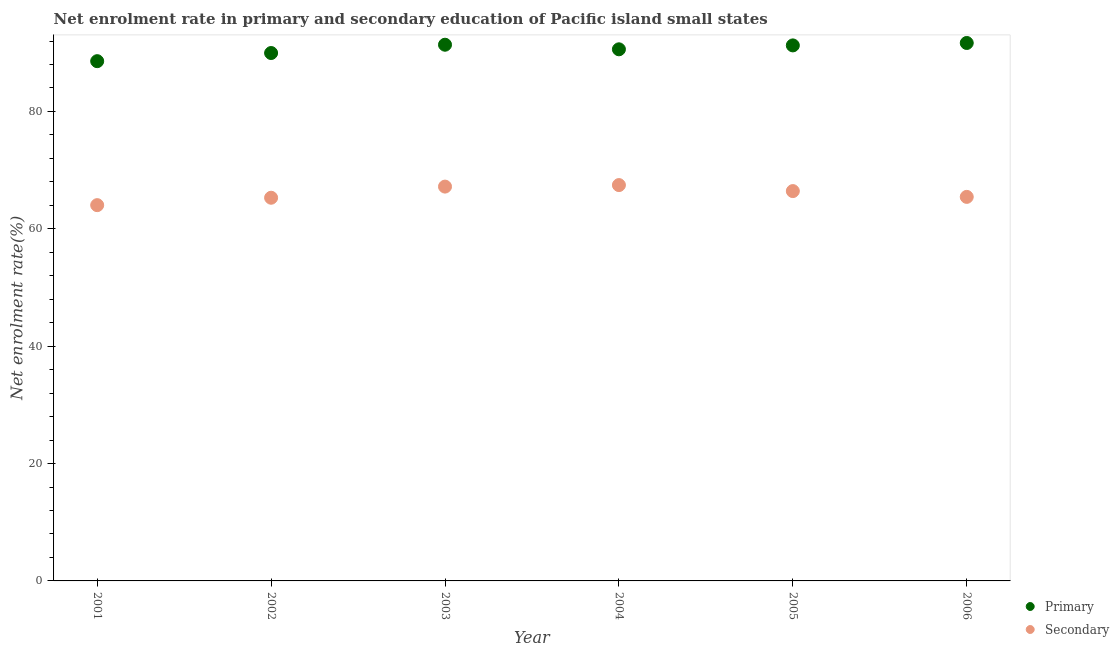What is the enrollment rate in secondary education in 2001?
Offer a very short reply. 64.03. Across all years, what is the maximum enrollment rate in primary education?
Make the answer very short. 91.66. Across all years, what is the minimum enrollment rate in primary education?
Your answer should be compact. 88.56. In which year was the enrollment rate in secondary education maximum?
Your answer should be very brief. 2004. In which year was the enrollment rate in secondary education minimum?
Your answer should be compact. 2001. What is the total enrollment rate in primary education in the graph?
Give a very brief answer. 543.38. What is the difference between the enrollment rate in secondary education in 2004 and that in 2006?
Your answer should be compact. 2.01. What is the difference between the enrollment rate in primary education in 2003 and the enrollment rate in secondary education in 2002?
Your answer should be compact. 26.07. What is the average enrollment rate in primary education per year?
Your response must be concise. 90.56. In the year 2003, what is the difference between the enrollment rate in primary education and enrollment rate in secondary education?
Give a very brief answer. 24.18. In how many years, is the enrollment rate in primary education greater than 68 %?
Give a very brief answer. 6. What is the ratio of the enrollment rate in secondary education in 2004 to that in 2005?
Offer a very short reply. 1.02. Is the enrollment rate in primary education in 2002 less than that in 2004?
Ensure brevity in your answer.  Yes. What is the difference between the highest and the second highest enrollment rate in secondary education?
Your answer should be very brief. 0.26. What is the difference between the highest and the lowest enrollment rate in primary education?
Ensure brevity in your answer.  3.1. In how many years, is the enrollment rate in primary education greater than the average enrollment rate in primary education taken over all years?
Your answer should be compact. 4. Is the sum of the enrollment rate in secondary education in 2005 and 2006 greater than the maximum enrollment rate in primary education across all years?
Ensure brevity in your answer.  Yes. Is the enrollment rate in secondary education strictly less than the enrollment rate in primary education over the years?
Offer a terse response. Yes. How many dotlines are there?
Give a very brief answer. 2. How many years are there in the graph?
Your answer should be compact. 6. Does the graph contain any zero values?
Ensure brevity in your answer.  No. How many legend labels are there?
Your answer should be very brief. 2. How are the legend labels stacked?
Offer a very short reply. Vertical. What is the title of the graph?
Make the answer very short. Net enrolment rate in primary and secondary education of Pacific island small states. Does "Education" appear as one of the legend labels in the graph?
Make the answer very short. No. What is the label or title of the Y-axis?
Offer a very short reply. Net enrolment rate(%). What is the Net enrolment rate(%) of Primary in 2001?
Give a very brief answer. 88.56. What is the Net enrolment rate(%) in Secondary in 2001?
Offer a very short reply. 64.03. What is the Net enrolment rate(%) of Primary in 2002?
Provide a succinct answer. 89.95. What is the Net enrolment rate(%) in Secondary in 2002?
Your response must be concise. 65.29. What is the Net enrolment rate(%) in Primary in 2003?
Offer a very short reply. 91.37. What is the Net enrolment rate(%) in Secondary in 2003?
Your answer should be compact. 67.19. What is the Net enrolment rate(%) in Primary in 2004?
Your response must be concise. 90.58. What is the Net enrolment rate(%) in Secondary in 2004?
Ensure brevity in your answer.  67.45. What is the Net enrolment rate(%) of Primary in 2005?
Provide a succinct answer. 91.25. What is the Net enrolment rate(%) in Secondary in 2005?
Give a very brief answer. 66.43. What is the Net enrolment rate(%) of Primary in 2006?
Your answer should be compact. 91.66. What is the Net enrolment rate(%) in Secondary in 2006?
Ensure brevity in your answer.  65.44. Across all years, what is the maximum Net enrolment rate(%) in Primary?
Keep it short and to the point. 91.66. Across all years, what is the maximum Net enrolment rate(%) of Secondary?
Give a very brief answer. 67.45. Across all years, what is the minimum Net enrolment rate(%) of Primary?
Offer a terse response. 88.56. Across all years, what is the minimum Net enrolment rate(%) in Secondary?
Provide a short and direct response. 64.03. What is the total Net enrolment rate(%) in Primary in the graph?
Provide a succinct answer. 543.38. What is the total Net enrolment rate(%) in Secondary in the graph?
Provide a succinct answer. 395.83. What is the difference between the Net enrolment rate(%) in Primary in 2001 and that in 2002?
Your response must be concise. -1.39. What is the difference between the Net enrolment rate(%) in Secondary in 2001 and that in 2002?
Offer a very short reply. -1.26. What is the difference between the Net enrolment rate(%) in Primary in 2001 and that in 2003?
Offer a terse response. -2.8. What is the difference between the Net enrolment rate(%) in Secondary in 2001 and that in 2003?
Offer a very short reply. -3.16. What is the difference between the Net enrolment rate(%) of Primary in 2001 and that in 2004?
Provide a short and direct response. -2.02. What is the difference between the Net enrolment rate(%) of Secondary in 2001 and that in 2004?
Make the answer very short. -3.42. What is the difference between the Net enrolment rate(%) of Primary in 2001 and that in 2005?
Your answer should be compact. -2.69. What is the difference between the Net enrolment rate(%) in Secondary in 2001 and that in 2005?
Offer a terse response. -2.39. What is the difference between the Net enrolment rate(%) in Primary in 2001 and that in 2006?
Make the answer very short. -3.1. What is the difference between the Net enrolment rate(%) of Secondary in 2001 and that in 2006?
Make the answer very short. -1.41. What is the difference between the Net enrolment rate(%) of Primary in 2002 and that in 2003?
Your answer should be compact. -1.41. What is the difference between the Net enrolment rate(%) of Secondary in 2002 and that in 2003?
Ensure brevity in your answer.  -1.9. What is the difference between the Net enrolment rate(%) of Primary in 2002 and that in 2004?
Your response must be concise. -0.63. What is the difference between the Net enrolment rate(%) in Secondary in 2002 and that in 2004?
Provide a succinct answer. -2.16. What is the difference between the Net enrolment rate(%) in Primary in 2002 and that in 2005?
Offer a terse response. -1.3. What is the difference between the Net enrolment rate(%) of Secondary in 2002 and that in 2005?
Give a very brief answer. -1.13. What is the difference between the Net enrolment rate(%) of Primary in 2002 and that in 2006?
Ensure brevity in your answer.  -1.71. What is the difference between the Net enrolment rate(%) in Secondary in 2002 and that in 2006?
Offer a very short reply. -0.15. What is the difference between the Net enrolment rate(%) in Primary in 2003 and that in 2004?
Give a very brief answer. 0.78. What is the difference between the Net enrolment rate(%) in Secondary in 2003 and that in 2004?
Ensure brevity in your answer.  -0.26. What is the difference between the Net enrolment rate(%) in Primary in 2003 and that in 2005?
Offer a terse response. 0.12. What is the difference between the Net enrolment rate(%) of Secondary in 2003 and that in 2005?
Offer a terse response. 0.77. What is the difference between the Net enrolment rate(%) in Primary in 2003 and that in 2006?
Provide a short and direct response. -0.3. What is the difference between the Net enrolment rate(%) of Secondary in 2003 and that in 2006?
Your answer should be compact. 1.75. What is the difference between the Net enrolment rate(%) in Primary in 2004 and that in 2005?
Ensure brevity in your answer.  -0.67. What is the difference between the Net enrolment rate(%) in Secondary in 2004 and that in 2005?
Your answer should be very brief. 1.02. What is the difference between the Net enrolment rate(%) in Primary in 2004 and that in 2006?
Make the answer very short. -1.08. What is the difference between the Net enrolment rate(%) in Secondary in 2004 and that in 2006?
Your answer should be very brief. 2.01. What is the difference between the Net enrolment rate(%) in Primary in 2005 and that in 2006?
Ensure brevity in your answer.  -0.41. What is the difference between the Net enrolment rate(%) in Secondary in 2005 and that in 2006?
Your answer should be compact. 0.99. What is the difference between the Net enrolment rate(%) of Primary in 2001 and the Net enrolment rate(%) of Secondary in 2002?
Provide a short and direct response. 23.27. What is the difference between the Net enrolment rate(%) in Primary in 2001 and the Net enrolment rate(%) in Secondary in 2003?
Your answer should be compact. 21.37. What is the difference between the Net enrolment rate(%) of Primary in 2001 and the Net enrolment rate(%) of Secondary in 2004?
Offer a terse response. 21.11. What is the difference between the Net enrolment rate(%) in Primary in 2001 and the Net enrolment rate(%) in Secondary in 2005?
Keep it short and to the point. 22.14. What is the difference between the Net enrolment rate(%) of Primary in 2001 and the Net enrolment rate(%) of Secondary in 2006?
Provide a short and direct response. 23.12. What is the difference between the Net enrolment rate(%) of Primary in 2002 and the Net enrolment rate(%) of Secondary in 2003?
Keep it short and to the point. 22.76. What is the difference between the Net enrolment rate(%) in Primary in 2002 and the Net enrolment rate(%) in Secondary in 2004?
Your response must be concise. 22.5. What is the difference between the Net enrolment rate(%) in Primary in 2002 and the Net enrolment rate(%) in Secondary in 2005?
Make the answer very short. 23.53. What is the difference between the Net enrolment rate(%) in Primary in 2002 and the Net enrolment rate(%) in Secondary in 2006?
Offer a very short reply. 24.51. What is the difference between the Net enrolment rate(%) in Primary in 2003 and the Net enrolment rate(%) in Secondary in 2004?
Your response must be concise. 23.92. What is the difference between the Net enrolment rate(%) in Primary in 2003 and the Net enrolment rate(%) in Secondary in 2005?
Your answer should be very brief. 24.94. What is the difference between the Net enrolment rate(%) in Primary in 2003 and the Net enrolment rate(%) in Secondary in 2006?
Provide a short and direct response. 25.93. What is the difference between the Net enrolment rate(%) of Primary in 2004 and the Net enrolment rate(%) of Secondary in 2005?
Provide a short and direct response. 24.16. What is the difference between the Net enrolment rate(%) in Primary in 2004 and the Net enrolment rate(%) in Secondary in 2006?
Offer a terse response. 25.15. What is the difference between the Net enrolment rate(%) of Primary in 2005 and the Net enrolment rate(%) of Secondary in 2006?
Your response must be concise. 25.81. What is the average Net enrolment rate(%) in Primary per year?
Your answer should be very brief. 90.56. What is the average Net enrolment rate(%) in Secondary per year?
Provide a succinct answer. 65.97. In the year 2001, what is the difference between the Net enrolment rate(%) in Primary and Net enrolment rate(%) in Secondary?
Your answer should be very brief. 24.53. In the year 2002, what is the difference between the Net enrolment rate(%) of Primary and Net enrolment rate(%) of Secondary?
Make the answer very short. 24.66. In the year 2003, what is the difference between the Net enrolment rate(%) in Primary and Net enrolment rate(%) in Secondary?
Your response must be concise. 24.18. In the year 2004, what is the difference between the Net enrolment rate(%) of Primary and Net enrolment rate(%) of Secondary?
Offer a very short reply. 23.13. In the year 2005, what is the difference between the Net enrolment rate(%) in Primary and Net enrolment rate(%) in Secondary?
Your answer should be very brief. 24.82. In the year 2006, what is the difference between the Net enrolment rate(%) in Primary and Net enrolment rate(%) in Secondary?
Offer a terse response. 26.22. What is the ratio of the Net enrolment rate(%) of Primary in 2001 to that in 2002?
Provide a succinct answer. 0.98. What is the ratio of the Net enrolment rate(%) in Secondary in 2001 to that in 2002?
Give a very brief answer. 0.98. What is the ratio of the Net enrolment rate(%) in Primary in 2001 to that in 2003?
Offer a very short reply. 0.97. What is the ratio of the Net enrolment rate(%) of Secondary in 2001 to that in 2003?
Provide a succinct answer. 0.95. What is the ratio of the Net enrolment rate(%) in Primary in 2001 to that in 2004?
Your response must be concise. 0.98. What is the ratio of the Net enrolment rate(%) in Secondary in 2001 to that in 2004?
Your answer should be compact. 0.95. What is the ratio of the Net enrolment rate(%) of Primary in 2001 to that in 2005?
Provide a succinct answer. 0.97. What is the ratio of the Net enrolment rate(%) in Primary in 2001 to that in 2006?
Keep it short and to the point. 0.97. What is the ratio of the Net enrolment rate(%) in Secondary in 2001 to that in 2006?
Provide a short and direct response. 0.98. What is the ratio of the Net enrolment rate(%) in Primary in 2002 to that in 2003?
Make the answer very short. 0.98. What is the ratio of the Net enrolment rate(%) of Secondary in 2002 to that in 2003?
Provide a short and direct response. 0.97. What is the ratio of the Net enrolment rate(%) in Secondary in 2002 to that in 2004?
Your answer should be very brief. 0.97. What is the ratio of the Net enrolment rate(%) in Primary in 2002 to that in 2005?
Offer a very short reply. 0.99. What is the ratio of the Net enrolment rate(%) of Secondary in 2002 to that in 2005?
Make the answer very short. 0.98. What is the ratio of the Net enrolment rate(%) in Primary in 2002 to that in 2006?
Provide a short and direct response. 0.98. What is the ratio of the Net enrolment rate(%) in Primary in 2003 to that in 2004?
Provide a succinct answer. 1.01. What is the ratio of the Net enrolment rate(%) in Secondary in 2003 to that in 2005?
Make the answer very short. 1.01. What is the ratio of the Net enrolment rate(%) in Secondary in 2003 to that in 2006?
Make the answer very short. 1.03. What is the ratio of the Net enrolment rate(%) in Secondary in 2004 to that in 2005?
Provide a succinct answer. 1.02. What is the ratio of the Net enrolment rate(%) in Secondary in 2004 to that in 2006?
Make the answer very short. 1.03. What is the ratio of the Net enrolment rate(%) of Primary in 2005 to that in 2006?
Your response must be concise. 1. What is the ratio of the Net enrolment rate(%) of Secondary in 2005 to that in 2006?
Make the answer very short. 1.02. What is the difference between the highest and the second highest Net enrolment rate(%) of Primary?
Your answer should be compact. 0.3. What is the difference between the highest and the second highest Net enrolment rate(%) of Secondary?
Offer a terse response. 0.26. What is the difference between the highest and the lowest Net enrolment rate(%) of Primary?
Ensure brevity in your answer.  3.1. What is the difference between the highest and the lowest Net enrolment rate(%) in Secondary?
Give a very brief answer. 3.42. 